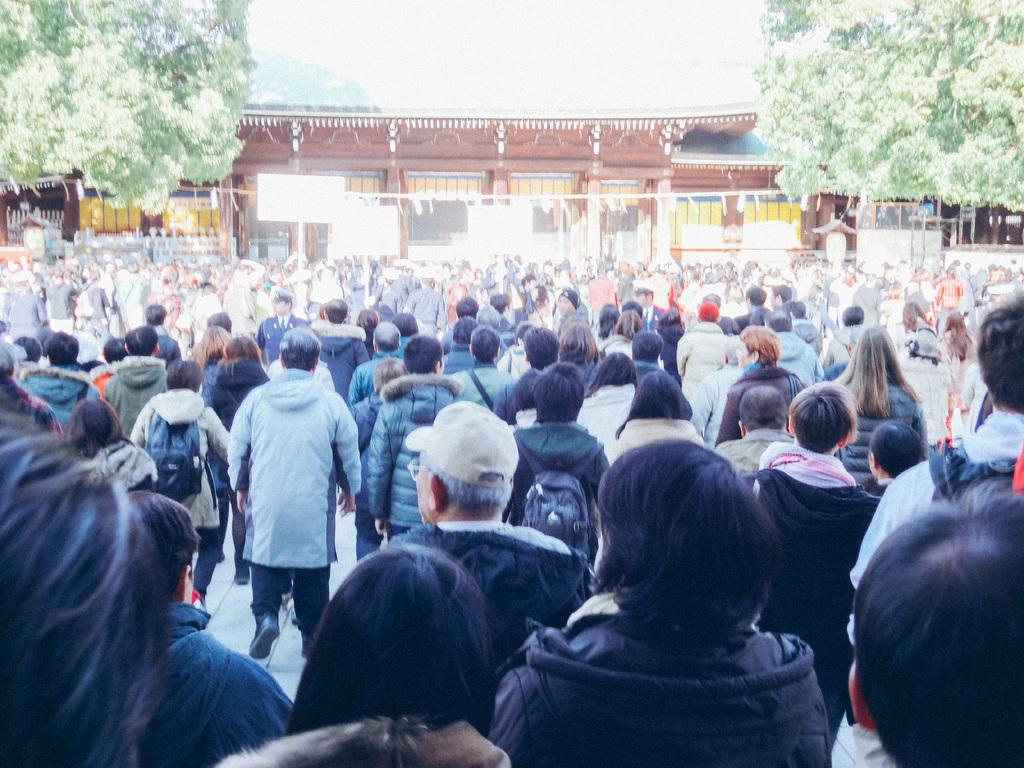How many people are visible in the image? There are many people standing in the image. What can be seen in the background of the image? There is a building and trees in the background of the image. What type of bean is being harvested by the people in the image? There is no bean or bean harvesting activity present in the image. What kind of ball can be seen being used by the people in the image? There is no ball present in the image. 